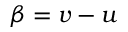<formula> <loc_0><loc_0><loc_500><loc_500>\beta = v - u</formula> 